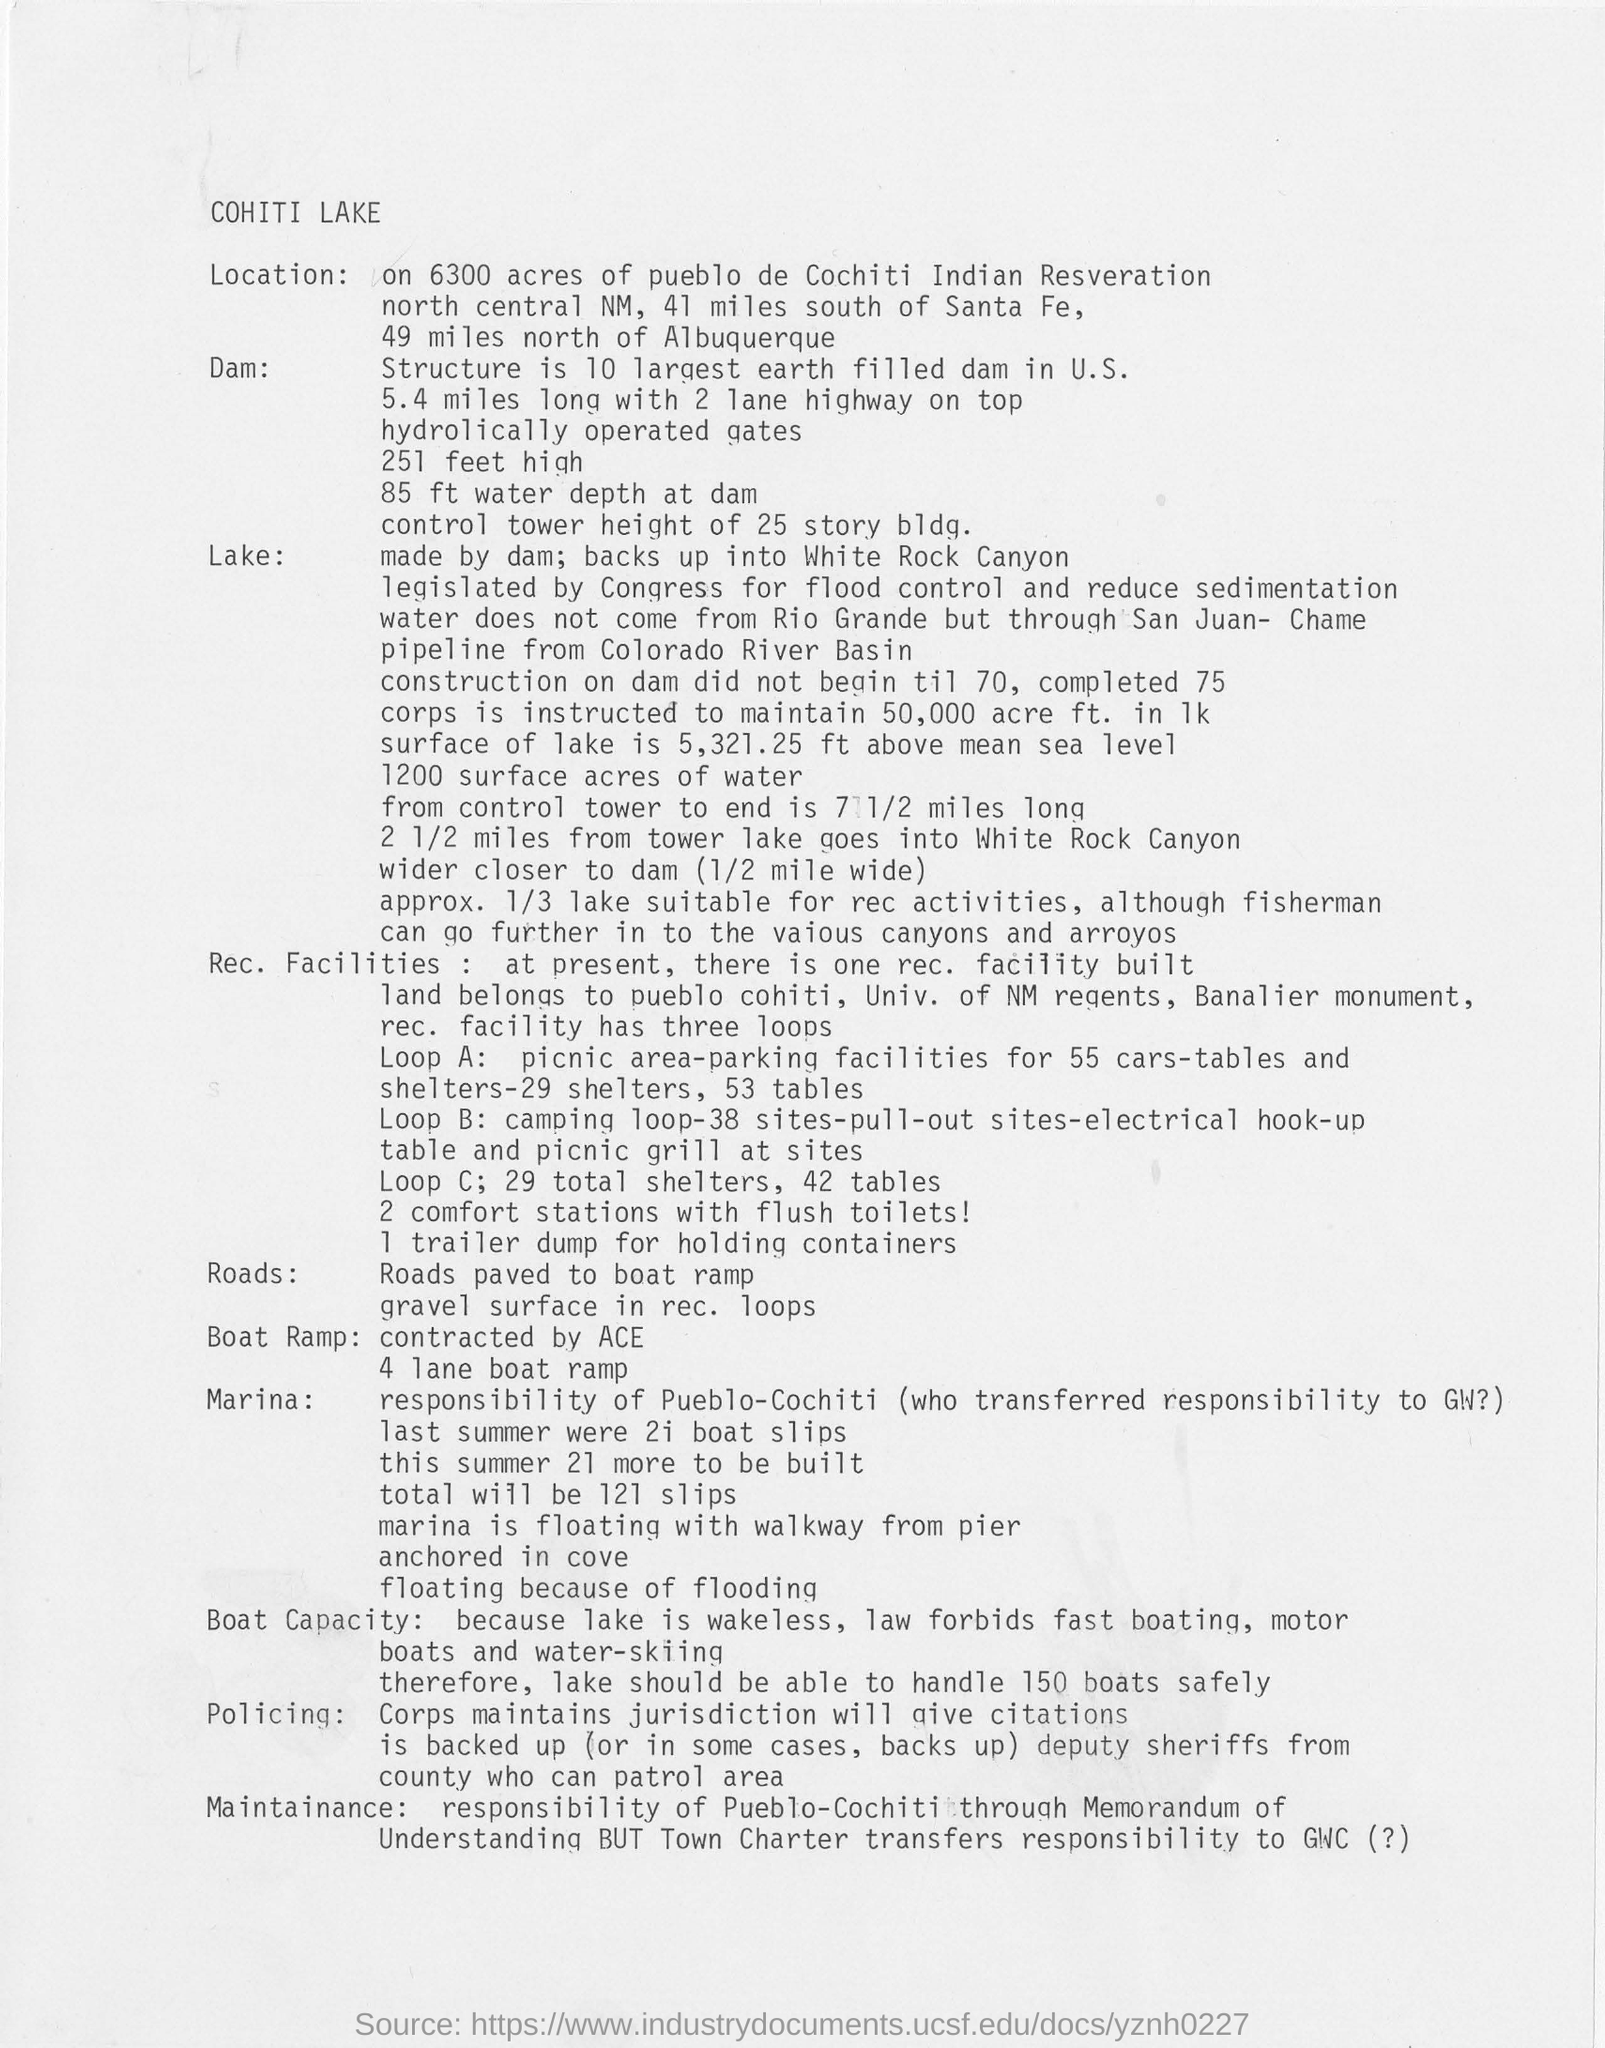Draw attention to some important aspects in this diagram. The name of the lake is Cohiti Lake. It is recommended that the lake be able to safely accommodate no more than 150 boats. The lake is located 49 miles north of Albuquerque. It is known that the boat ramp was contracted by ACE. 